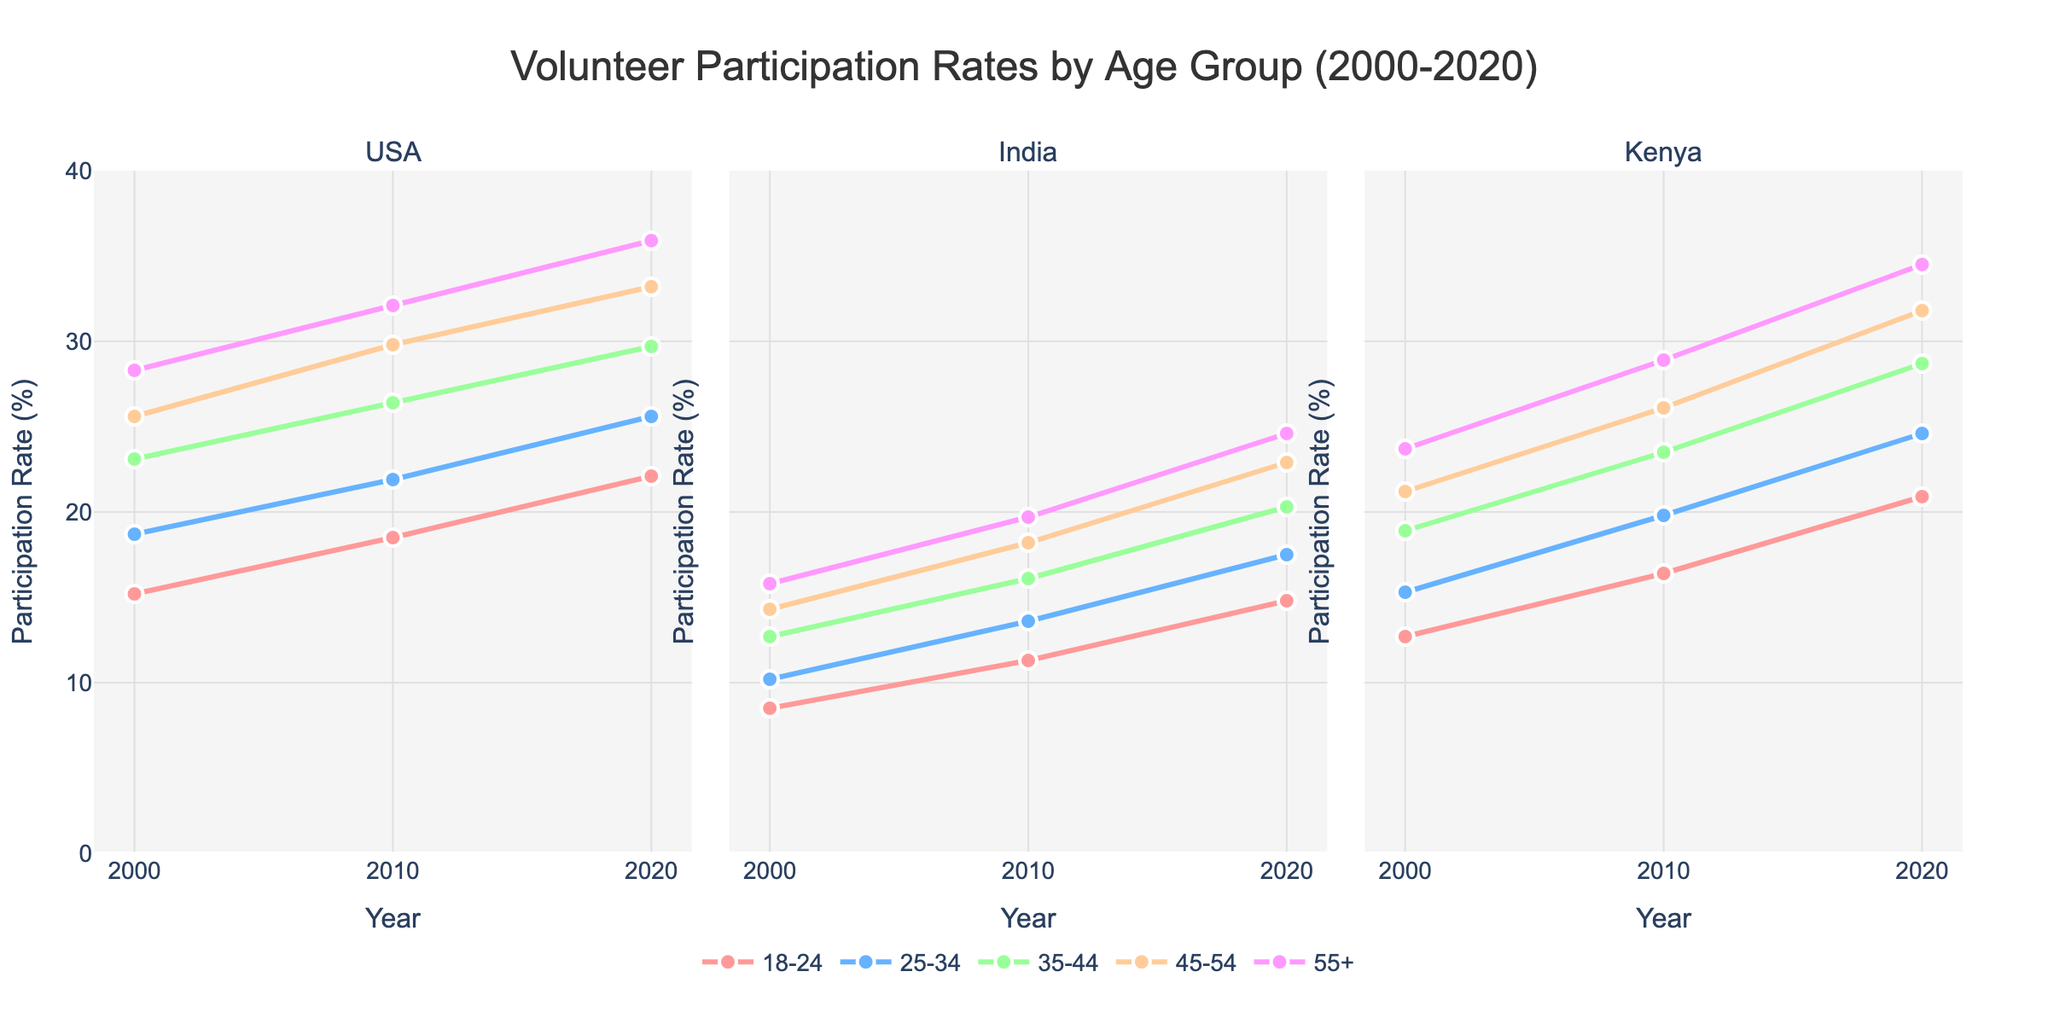What is the title of the graph? The title of the graph provides an overview of what the data is about. The title in large font at the top of the figure is ‘Volunteer Participation Rates by Age Group (2000-2020)’.
Answer: Volunteer Participation Rates by Age Group (2000-2020) Across all three countries, which age group had the highest participation rate in 2020? By looking at the end of the lines for 2020 across subplots for the USA, India, and Kenya, we see that the age group 55+ has the highest values in each subplot: USA (35.9%), India (24.6%), and Kenya (34.5%).
Answer: 55+ Which country had the highest overall participation rate in 2020 for the 45-54 age group? In the 2020 column, find the data points for the 45-54 age group in each country's subplot. For the USA, it is 33.2%, for India, it is 22.9%, and for Kenya, it is 31.8%. Therefore, the USA has the highest rate.
Answer: USA How did the participation rate in the 18-24 age group change in the USA from 2000 to 2020? Compare the points for the 18-24 age group in the USA subplot for the years 2000, 2010, and 2020. The rates go from 15.2% (2000) to 18.5% (2010) to 22.1% (2020), showing an increase.
Answer: Increased Which country showed the highest increase in volunteer participation for the 25-34 age group from 2000 to 2020? Calculate the increase for the 25-34 age group in each country's subplot from 2000 to 2020. USA: 25.6% - 18.7% = 6.9%, India: 17.5% - 10.2% = 7.3%, Kenya: 24.6% - 15.3% = 9.3%. Thus, Kenya showed the highest increase.
Answer: Kenya Was the participation rate for the 35-44 age group higher in India or Kenya in 2010? Find the respective points for the 35-44 age group in 2010 for India and Kenya. India's rate is 16.1%, while Kenya's rate is 23.5%. Therefore, Kenya's rate was higher.
Answer: Kenya In which country and for which age group did participation rates increase the least from 2000 to 2020? Compare the increases for each age group within the countries from 2000 to 2020. Calculate the differences: USA, India, Kenya. The smallest increase is for India in the 55+ age group: 24.6% - 15.8% = 8.8%.
Answer: India, 55+ Which two age groups had the closest participation rates in the USA in 2010? Compare the 2010 participation rates across age groups in the USA subplot. The 18-24 group had 18.5% and the 25-34 group had 21.9%, with their difference being 3.4%, the smallest difference among the groups.
Answer: 18-24 and 25-34 By how many percentage points did the participation rate in the 55+ age group increase in Kenya from 2000 to 2020? Find and subtract the 2000 and 2020 data points for Kenya's 55+ age group. Its values are 23.7% (2000) and 34.5% (2020), resulting in an increase of 34.5% - 23.7% = 10.8%.
Answer: 10.8 